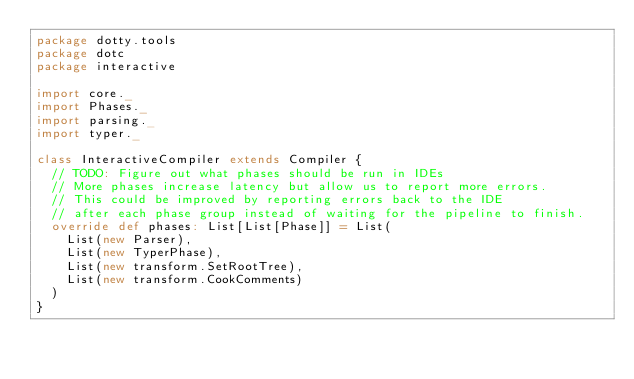Convert code to text. <code><loc_0><loc_0><loc_500><loc_500><_Scala_>package dotty.tools
package dotc
package interactive

import core._
import Phases._
import parsing._
import typer._

class InteractiveCompiler extends Compiler {
  // TODO: Figure out what phases should be run in IDEs
  // More phases increase latency but allow us to report more errors.
  // This could be improved by reporting errors back to the IDE
  // after each phase group instead of waiting for the pipeline to finish.
  override def phases: List[List[Phase]] = List(
    List(new Parser),
    List(new TyperPhase),
    List(new transform.SetRootTree),
    List(new transform.CookComments)
  )
}
</code> 